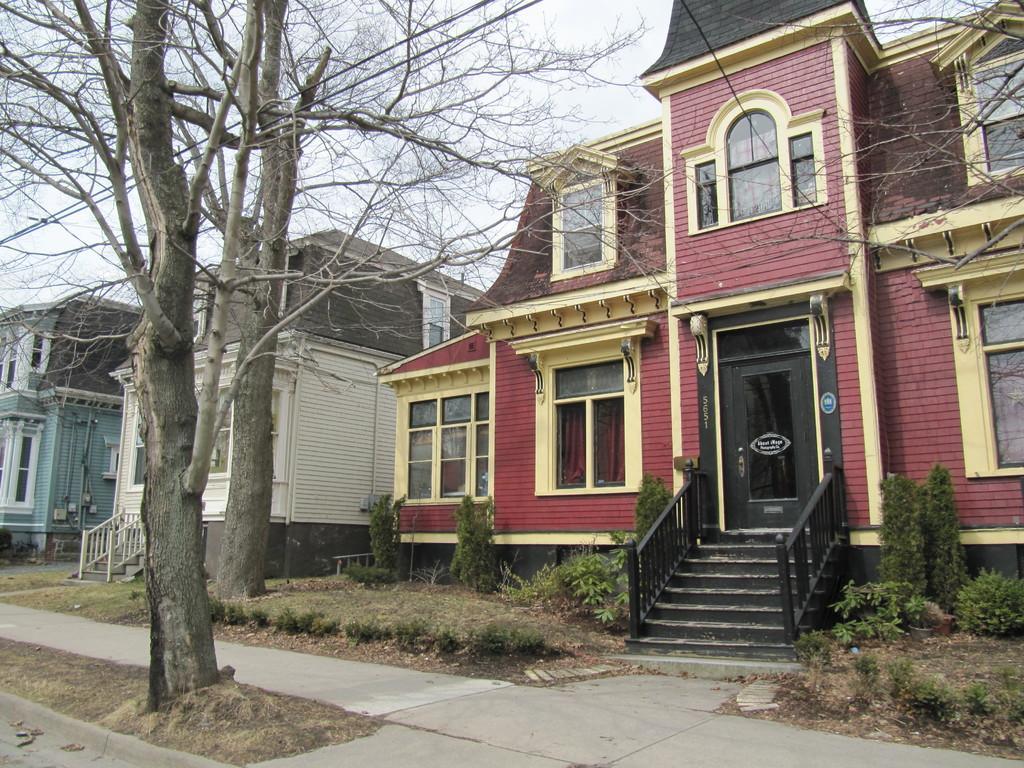Please provide a concise description of this image. In the picture we can see a path to it, we can see a dried tree and beside it, we can see another dried tree and near it, we can see some grass plants and near it, we can see a house with doors, windows, steps and railing to it and besides also we can see some houses and in the background we can see some wires and sky. 